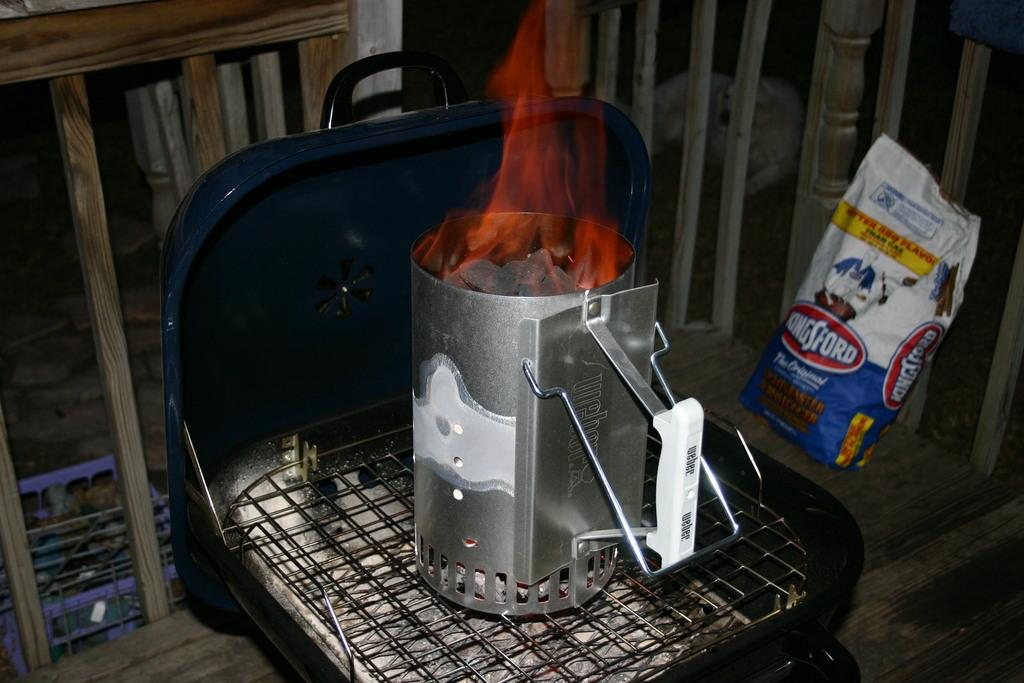<image>
Provide a brief description of the given image. A bag of Kingsford charcoal sits near the barbecue grill. 